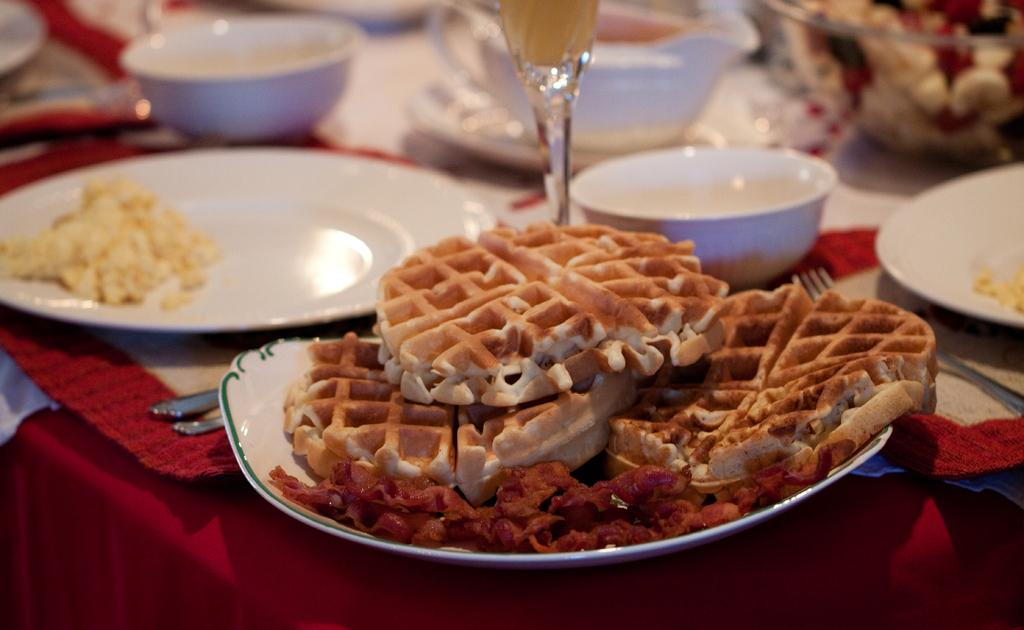What type of dishware can be seen in the image? There are plates and bowls in the image. What is present in the dishes? There is food in the image. Where is the food located? The food is on a platform in the image. How many spiders are crawling on the plates in the image? There are no spiders present in the image; it only features plates, bowls, and food. 